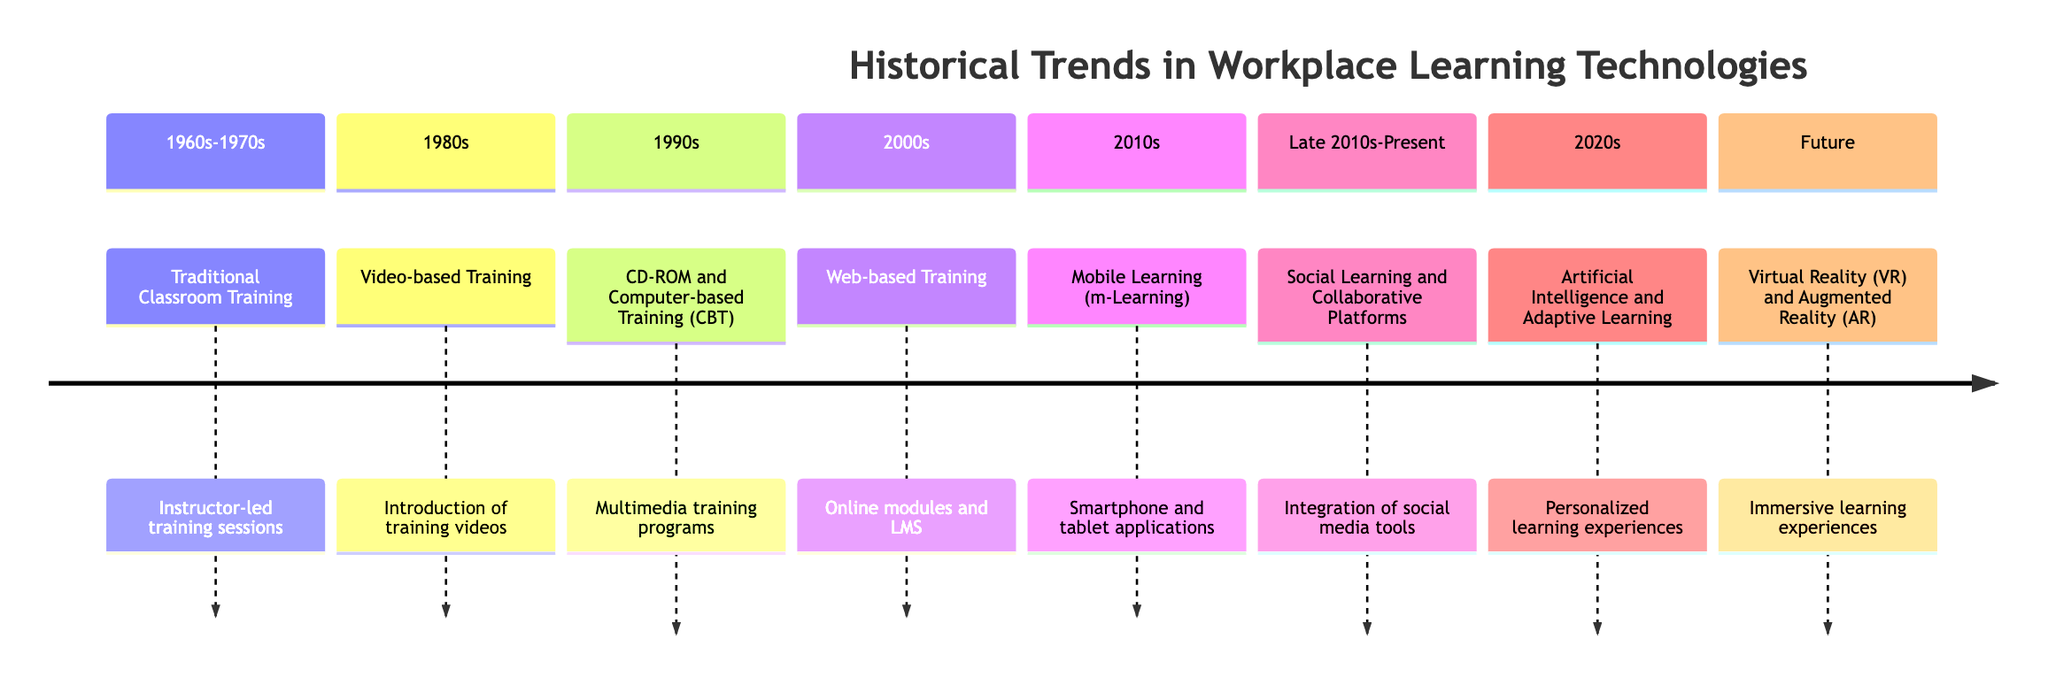What type of training was prevalent in the 1970s? The diagram specifies that the technology during the 1960s-1970s was "Traditional Classroom Training," indicating that this was the primary method of training in that time period.
Answer: Traditional Classroom Training How many sections are there in the timeline? By counting the number of distinct periods listed in the timeline, we find there are a total of eight sections, which include each decade and the future period.
Answer: 8 What technology was introduced in the 1980s? The diagram indicates that in the 1980s, the technology was "Video-based Training," which focuses on the use of training videos for learning.
Answer: Video-based Training Which decade saw the rise of Mobile Learning? According to the timeline, the 2010s marked the rise of "Mobile Learning (m-Learning)," indicating that this technology became prominent during that decade.
Answer: 2010s What key advancement occurred in the 2020s? The timeline specifies that the key advancement in the 2020s is "Artificial Intelligence and Adaptive Learning," highlighting the importance of AI in personalizing learning experiences during this period.
Answer: Artificial Intelligence and Adaptive Learning Which training method allows for interaction on personal computers? The timeline indicates that "CD-ROM and Computer-based Training (CBT)" in the 1990s allowed employees to interact with multimedia training programs on their computers at their own pace.
Answer: CD-ROM and Computer-based Training (CBT) What type of learning platforms emerged in the late 2010s? The diagram mentions "Social Learning and Collaborative Platforms" as the significant development in the late 2010s, emphasizing the integration of social media and collaboration in learning.
Answer: Social Learning and Collaborative Platforms What emerging technology is expected to create immersive experiences in the future? The timeline states that the future will involve "Virtual Reality (VR) and Augmented Reality (AR)," which are expected to provide immersive learning experiences and real-time interactive training environments.
Answer: Virtual Reality (VR) and Augmented Reality (AR) 